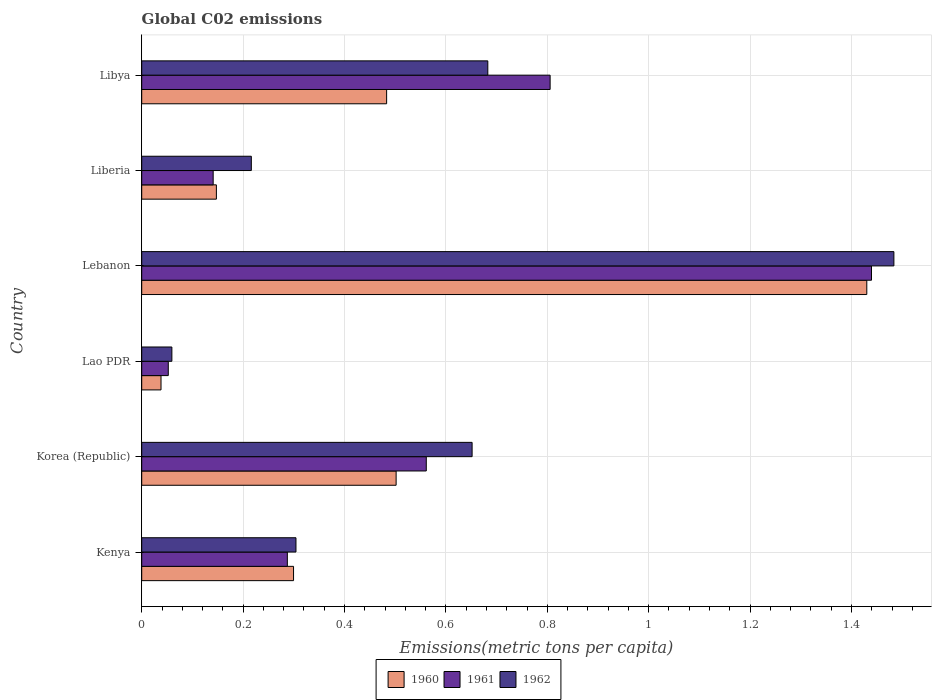How many groups of bars are there?
Your response must be concise. 6. Are the number of bars per tick equal to the number of legend labels?
Offer a very short reply. Yes. Are the number of bars on each tick of the Y-axis equal?
Ensure brevity in your answer.  Yes. What is the label of the 2nd group of bars from the top?
Your answer should be very brief. Liberia. In how many cases, is the number of bars for a given country not equal to the number of legend labels?
Make the answer very short. 0. What is the amount of CO2 emitted in in 1960 in Lao PDR?
Provide a succinct answer. 0.04. Across all countries, what is the maximum amount of CO2 emitted in in 1960?
Provide a succinct answer. 1.43. Across all countries, what is the minimum amount of CO2 emitted in in 1962?
Your answer should be compact. 0.06. In which country was the amount of CO2 emitted in in 1960 maximum?
Offer a terse response. Lebanon. In which country was the amount of CO2 emitted in in 1960 minimum?
Give a very brief answer. Lao PDR. What is the total amount of CO2 emitted in in 1960 in the graph?
Give a very brief answer. 2.9. What is the difference between the amount of CO2 emitted in in 1960 in Lao PDR and that in Liberia?
Give a very brief answer. -0.11. What is the difference between the amount of CO2 emitted in in 1961 in Liberia and the amount of CO2 emitted in in 1962 in Lebanon?
Provide a short and direct response. -1.34. What is the average amount of CO2 emitted in in 1962 per country?
Ensure brevity in your answer.  0.57. What is the difference between the amount of CO2 emitted in in 1962 and amount of CO2 emitted in in 1961 in Lebanon?
Offer a terse response. 0.04. In how many countries, is the amount of CO2 emitted in in 1961 greater than 0.24000000000000002 metric tons per capita?
Offer a very short reply. 4. What is the ratio of the amount of CO2 emitted in in 1961 in Kenya to that in Korea (Republic)?
Make the answer very short. 0.51. Is the amount of CO2 emitted in in 1962 in Lebanon less than that in Libya?
Your response must be concise. No. Is the difference between the amount of CO2 emitted in in 1962 in Kenya and Korea (Republic) greater than the difference between the amount of CO2 emitted in in 1961 in Kenya and Korea (Republic)?
Ensure brevity in your answer.  No. What is the difference between the highest and the second highest amount of CO2 emitted in in 1961?
Your answer should be very brief. 0.63. What is the difference between the highest and the lowest amount of CO2 emitted in in 1962?
Provide a short and direct response. 1.42. Is the sum of the amount of CO2 emitted in in 1962 in Kenya and Libya greater than the maximum amount of CO2 emitted in in 1960 across all countries?
Your answer should be very brief. No. How many bars are there?
Your response must be concise. 18. Are all the bars in the graph horizontal?
Provide a short and direct response. Yes. How many countries are there in the graph?
Your answer should be compact. 6. Does the graph contain grids?
Provide a succinct answer. Yes. Where does the legend appear in the graph?
Keep it short and to the point. Bottom center. How many legend labels are there?
Make the answer very short. 3. How are the legend labels stacked?
Make the answer very short. Horizontal. What is the title of the graph?
Make the answer very short. Global C02 emissions. Does "1995" appear as one of the legend labels in the graph?
Provide a short and direct response. No. What is the label or title of the X-axis?
Offer a very short reply. Emissions(metric tons per capita). What is the label or title of the Y-axis?
Offer a very short reply. Country. What is the Emissions(metric tons per capita) of 1960 in Kenya?
Your answer should be compact. 0.3. What is the Emissions(metric tons per capita) in 1961 in Kenya?
Your answer should be very brief. 0.29. What is the Emissions(metric tons per capita) in 1962 in Kenya?
Your answer should be very brief. 0.3. What is the Emissions(metric tons per capita) in 1960 in Korea (Republic)?
Offer a very short reply. 0.5. What is the Emissions(metric tons per capita) in 1961 in Korea (Republic)?
Offer a very short reply. 0.56. What is the Emissions(metric tons per capita) of 1962 in Korea (Republic)?
Your answer should be very brief. 0.65. What is the Emissions(metric tons per capita) of 1960 in Lao PDR?
Your answer should be very brief. 0.04. What is the Emissions(metric tons per capita) in 1961 in Lao PDR?
Your answer should be very brief. 0.05. What is the Emissions(metric tons per capita) in 1962 in Lao PDR?
Provide a succinct answer. 0.06. What is the Emissions(metric tons per capita) of 1960 in Lebanon?
Provide a succinct answer. 1.43. What is the Emissions(metric tons per capita) in 1961 in Lebanon?
Keep it short and to the point. 1.44. What is the Emissions(metric tons per capita) of 1962 in Lebanon?
Your answer should be very brief. 1.48. What is the Emissions(metric tons per capita) of 1960 in Liberia?
Give a very brief answer. 0.15. What is the Emissions(metric tons per capita) of 1961 in Liberia?
Provide a succinct answer. 0.14. What is the Emissions(metric tons per capita) in 1962 in Liberia?
Provide a short and direct response. 0.22. What is the Emissions(metric tons per capita) in 1960 in Libya?
Your answer should be compact. 0.48. What is the Emissions(metric tons per capita) in 1961 in Libya?
Keep it short and to the point. 0.81. What is the Emissions(metric tons per capita) of 1962 in Libya?
Give a very brief answer. 0.68. Across all countries, what is the maximum Emissions(metric tons per capita) of 1960?
Provide a succinct answer. 1.43. Across all countries, what is the maximum Emissions(metric tons per capita) of 1961?
Your response must be concise. 1.44. Across all countries, what is the maximum Emissions(metric tons per capita) in 1962?
Provide a succinct answer. 1.48. Across all countries, what is the minimum Emissions(metric tons per capita) in 1960?
Offer a very short reply. 0.04. Across all countries, what is the minimum Emissions(metric tons per capita) of 1961?
Give a very brief answer. 0.05. Across all countries, what is the minimum Emissions(metric tons per capita) of 1962?
Your response must be concise. 0.06. What is the total Emissions(metric tons per capita) of 1960 in the graph?
Offer a very short reply. 2.9. What is the total Emissions(metric tons per capita) of 1961 in the graph?
Provide a short and direct response. 3.29. What is the total Emissions(metric tons per capita) in 1962 in the graph?
Your answer should be compact. 3.4. What is the difference between the Emissions(metric tons per capita) in 1960 in Kenya and that in Korea (Republic)?
Your answer should be very brief. -0.2. What is the difference between the Emissions(metric tons per capita) in 1961 in Kenya and that in Korea (Republic)?
Your response must be concise. -0.27. What is the difference between the Emissions(metric tons per capita) in 1962 in Kenya and that in Korea (Republic)?
Your response must be concise. -0.35. What is the difference between the Emissions(metric tons per capita) of 1960 in Kenya and that in Lao PDR?
Give a very brief answer. 0.26. What is the difference between the Emissions(metric tons per capita) of 1961 in Kenya and that in Lao PDR?
Give a very brief answer. 0.23. What is the difference between the Emissions(metric tons per capita) of 1962 in Kenya and that in Lao PDR?
Your answer should be compact. 0.24. What is the difference between the Emissions(metric tons per capita) of 1960 in Kenya and that in Lebanon?
Offer a very short reply. -1.13. What is the difference between the Emissions(metric tons per capita) of 1961 in Kenya and that in Lebanon?
Keep it short and to the point. -1.15. What is the difference between the Emissions(metric tons per capita) of 1962 in Kenya and that in Lebanon?
Keep it short and to the point. -1.18. What is the difference between the Emissions(metric tons per capita) of 1960 in Kenya and that in Liberia?
Ensure brevity in your answer.  0.15. What is the difference between the Emissions(metric tons per capita) in 1961 in Kenya and that in Liberia?
Provide a succinct answer. 0.15. What is the difference between the Emissions(metric tons per capita) in 1962 in Kenya and that in Liberia?
Your answer should be very brief. 0.09. What is the difference between the Emissions(metric tons per capita) of 1960 in Kenya and that in Libya?
Give a very brief answer. -0.18. What is the difference between the Emissions(metric tons per capita) in 1961 in Kenya and that in Libya?
Your answer should be very brief. -0.52. What is the difference between the Emissions(metric tons per capita) of 1962 in Kenya and that in Libya?
Your answer should be compact. -0.38. What is the difference between the Emissions(metric tons per capita) in 1960 in Korea (Republic) and that in Lao PDR?
Your answer should be very brief. 0.46. What is the difference between the Emissions(metric tons per capita) of 1961 in Korea (Republic) and that in Lao PDR?
Provide a succinct answer. 0.51. What is the difference between the Emissions(metric tons per capita) of 1962 in Korea (Republic) and that in Lao PDR?
Make the answer very short. 0.59. What is the difference between the Emissions(metric tons per capita) in 1960 in Korea (Republic) and that in Lebanon?
Your response must be concise. -0.93. What is the difference between the Emissions(metric tons per capita) of 1961 in Korea (Republic) and that in Lebanon?
Provide a succinct answer. -0.88. What is the difference between the Emissions(metric tons per capita) in 1962 in Korea (Republic) and that in Lebanon?
Provide a short and direct response. -0.83. What is the difference between the Emissions(metric tons per capita) in 1960 in Korea (Republic) and that in Liberia?
Offer a terse response. 0.35. What is the difference between the Emissions(metric tons per capita) in 1961 in Korea (Republic) and that in Liberia?
Offer a very short reply. 0.42. What is the difference between the Emissions(metric tons per capita) of 1962 in Korea (Republic) and that in Liberia?
Your response must be concise. 0.44. What is the difference between the Emissions(metric tons per capita) of 1960 in Korea (Republic) and that in Libya?
Offer a terse response. 0.02. What is the difference between the Emissions(metric tons per capita) in 1961 in Korea (Republic) and that in Libya?
Keep it short and to the point. -0.24. What is the difference between the Emissions(metric tons per capita) of 1962 in Korea (Republic) and that in Libya?
Your answer should be compact. -0.03. What is the difference between the Emissions(metric tons per capita) of 1960 in Lao PDR and that in Lebanon?
Make the answer very short. -1.39. What is the difference between the Emissions(metric tons per capita) of 1961 in Lao PDR and that in Lebanon?
Offer a very short reply. -1.39. What is the difference between the Emissions(metric tons per capita) in 1962 in Lao PDR and that in Lebanon?
Keep it short and to the point. -1.42. What is the difference between the Emissions(metric tons per capita) of 1960 in Lao PDR and that in Liberia?
Keep it short and to the point. -0.11. What is the difference between the Emissions(metric tons per capita) of 1961 in Lao PDR and that in Liberia?
Offer a terse response. -0.09. What is the difference between the Emissions(metric tons per capita) in 1962 in Lao PDR and that in Liberia?
Your answer should be compact. -0.16. What is the difference between the Emissions(metric tons per capita) in 1960 in Lao PDR and that in Libya?
Offer a terse response. -0.45. What is the difference between the Emissions(metric tons per capita) of 1961 in Lao PDR and that in Libya?
Keep it short and to the point. -0.75. What is the difference between the Emissions(metric tons per capita) of 1962 in Lao PDR and that in Libya?
Offer a terse response. -0.62. What is the difference between the Emissions(metric tons per capita) of 1960 in Lebanon and that in Liberia?
Offer a terse response. 1.28. What is the difference between the Emissions(metric tons per capita) in 1961 in Lebanon and that in Liberia?
Provide a short and direct response. 1.3. What is the difference between the Emissions(metric tons per capita) of 1962 in Lebanon and that in Liberia?
Provide a succinct answer. 1.27. What is the difference between the Emissions(metric tons per capita) of 1960 in Lebanon and that in Libya?
Your answer should be compact. 0.95. What is the difference between the Emissions(metric tons per capita) of 1961 in Lebanon and that in Libya?
Give a very brief answer. 0.63. What is the difference between the Emissions(metric tons per capita) in 1962 in Lebanon and that in Libya?
Keep it short and to the point. 0.8. What is the difference between the Emissions(metric tons per capita) of 1960 in Liberia and that in Libya?
Provide a short and direct response. -0.34. What is the difference between the Emissions(metric tons per capita) of 1961 in Liberia and that in Libya?
Your answer should be very brief. -0.66. What is the difference between the Emissions(metric tons per capita) in 1962 in Liberia and that in Libya?
Your answer should be very brief. -0.47. What is the difference between the Emissions(metric tons per capita) in 1960 in Kenya and the Emissions(metric tons per capita) in 1961 in Korea (Republic)?
Make the answer very short. -0.26. What is the difference between the Emissions(metric tons per capita) in 1960 in Kenya and the Emissions(metric tons per capita) in 1962 in Korea (Republic)?
Your response must be concise. -0.35. What is the difference between the Emissions(metric tons per capita) of 1961 in Kenya and the Emissions(metric tons per capita) of 1962 in Korea (Republic)?
Make the answer very short. -0.36. What is the difference between the Emissions(metric tons per capita) of 1960 in Kenya and the Emissions(metric tons per capita) of 1961 in Lao PDR?
Provide a succinct answer. 0.25. What is the difference between the Emissions(metric tons per capita) in 1960 in Kenya and the Emissions(metric tons per capita) in 1962 in Lao PDR?
Give a very brief answer. 0.24. What is the difference between the Emissions(metric tons per capita) of 1961 in Kenya and the Emissions(metric tons per capita) of 1962 in Lao PDR?
Keep it short and to the point. 0.23. What is the difference between the Emissions(metric tons per capita) in 1960 in Kenya and the Emissions(metric tons per capita) in 1961 in Lebanon?
Your answer should be compact. -1.14. What is the difference between the Emissions(metric tons per capita) in 1960 in Kenya and the Emissions(metric tons per capita) in 1962 in Lebanon?
Make the answer very short. -1.18. What is the difference between the Emissions(metric tons per capita) in 1961 in Kenya and the Emissions(metric tons per capita) in 1962 in Lebanon?
Give a very brief answer. -1.2. What is the difference between the Emissions(metric tons per capita) in 1960 in Kenya and the Emissions(metric tons per capita) in 1961 in Liberia?
Your response must be concise. 0.16. What is the difference between the Emissions(metric tons per capita) in 1960 in Kenya and the Emissions(metric tons per capita) in 1962 in Liberia?
Offer a terse response. 0.08. What is the difference between the Emissions(metric tons per capita) in 1961 in Kenya and the Emissions(metric tons per capita) in 1962 in Liberia?
Give a very brief answer. 0.07. What is the difference between the Emissions(metric tons per capita) in 1960 in Kenya and the Emissions(metric tons per capita) in 1961 in Libya?
Your answer should be very brief. -0.51. What is the difference between the Emissions(metric tons per capita) in 1960 in Kenya and the Emissions(metric tons per capita) in 1962 in Libya?
Provide a succinct answer. -0.38. What is the difference between the Emissions(metric tons per capita) in 1961 in Kenya and the Emissions(metric tons per capita) in 1962 in Libya?
Make the answer very short. -0.4. What is the difference between the Emissions(metric tons per capita) in 1960 in Korea (Republic) and the Emissions(metric tons per capita) in 1961 in Lao PDR?
Provide a succinct answer. 0.45. What is the difference between the Emissions(metric tons per capita) in 1960 in Korea (Republic) and the Emissions(metric tons per capita) in 1962 in Lao PDR?
Provide a succinct answer. 0.44. What is the difference between the Emissions(metric tons per capita) of 1961 in Korea (Republic) and the Emissions(metric tons per capita) of 1962 in Lao PDR?
Provide a short and direct response. 0.5. What is the difference between the Emissions(metric tons per capita) of 1960 in Korea (Republic) and the Emissions(metric tons per capita) of 1961 in Lebanon?
Give a very brief answer. -0.94. What is the difference between the Emissions(metric tons per capita) in 1960 in Korea (Republic) and the Emissions(metric tons per capita) in 1962 in Lebanon?
Ensure brevity in your answer.  -0.98. What is the difference between the Emissions(metric tons per capita) in 1961 in Korea (Republic) and the Emissions(metric tons per capita) in 1962 in Lebanon?
Your response must be concise. -0.92. What is the difference between the Emissions(metric tons per capita) in 1960 in Korea (Republic) and the Emissions(metric tons per capita) in 1961 in Liberia?
Give a very brief answer. 0.36. What is the difference between the Emissions(metric tons per capita) in 1960 in Korea (Republic) and the Emissions(metric tons per capita) in 1962 in Liberia?
Keep it short and to the point. 0.29. What is the difference between the Emissions(metric tons per capita) of 1961 in Korea (Republic) and the Emissions(metric tons per capita) of 1962 in Liberia?
Your answer should be very brief. 0.35. What is the difference between the Emissions(metric tons per capita) of 1960 in Korea (Republic) and the Emissions(metric tons per capita) of 1961 in Libya?
Provide a short and direct response. -0.3. What is the difference between the Emissions(metric tons per capita) of 1960 in Korea (Republic) and the Emissions(metric tons per capita) of 1962 in Libya?
Make the answer very short. -0.18. What is the difference between the Emissions(metric tons per capita) in 1961 in Korea (Republic) and the Emissions(metric tons per capita) in 1962 in Libya?
Your response must be concise. -0.12. What is the difference between the Emissions(metric tons per capita) of 1960 in Lao PDR and the Emissions(metric tons per capita) of 1961 in Lebanon?
Your response must be concise. -1.4. What is the difference between the Emissions(metric tons per capita) of 1960 in Lao PDR and the Emissions(metric tons per capita) of 1962 in Lebanon?
Provide a short and direct response. -1.45. What is the difference between the Emissions(metric tons per capita) in 1961 in Lao PDR and the Emissions(metric tons per capita) in 1962 in Lebanon?
Ensure brevity in your answer.  -1.43. What is the difference between the Emissions(metric tons per capita) of 1960 in Lao PDR and the Emissions(metric tons per capita) of 1961 in Liberia?
Provide a succinct answer. -0.1. What is the difference between the Emissions(metric tons per capita) in 1960 in Lao PDR and the Emissions(metric tons per capita) in 1962 in Liberia?
Provide a short and direct response. -0.18. What is the difference between the Emissions(metric tons per capita) of 1961 in Lao PDR and the Emissions(metric tons per capita) of 1962 in Liberia?
Give a very brief answer. -0.16. What is the difference between the Emissions(metric tons per capita) of 1960 in Lao PDR and the Emissions(metric tons per capita) of 1961 in Libya?
Provide a succinct answer. -0.77. What is the difference between the Emissions(metric tons per capita) of 1960 in Lao PDR and the Emissions(metric tons per capita) of 1962 in Libya?
Ensure brevity in your answer.  -0.64. What is the difference between the Emissions(metric tons per capita) of 1961 in Lao PDR and the Emissions(metric tons per capita) of 1962 in Libya?
Ensure brevity in your answer.  -0.63. What is the difference between the Emissions(metric tons per capita) of 1960 in Lebanon and the Emissions(metric tons per capita) of 1961 in Liberia?
Ensure brevity in your answer.  1.29. What is the difference between the Emissions(metric tons per capita) in 1960 in Lebanon and the Emissions(metric tons per capita) in 1962 in Liberia?
Provide a succinct answer. 1.21. What is the difference between the Emissions(metric tons per capita) in 1961 in Lebanon and the Emissions(metric tons per capita) in 1962 in Liberia?
Provide a short and direct response. 1.22. What is the difference between the Emissions(metric tons per capita) in 1960 in Lebanon and the Emissions(metric tons per capita) in 1961 in Libya?
Provide a short and direct response. 0.62. What is the difference between the Emissions(metric tons per capita) in 1960 in Lebanon and the Emissions(metric tons per capita) in 1962 in Libya?
Provide a short and direct response. 0.75. What is the difference between the Emissions(metric tons per capita) of 1961 in Lebanon and the Emissions(metric tons per capita) of 1962 in Libya?
Provide a short and direct response. 0.76. What is the difference between the Emissions(metric tons per capita) in 1960 in Liberia and the Emissions(metric tons per capita) in 1961 in Libya?
Give a very brief answer. -0.66. What is the difference between the Emissions(metric tons per capita) of 1960 in Liberia and the Emissions(metric tons per capita) of 1962 in Libya?
Make the answer very short. -0.54. What is the difference between the Emissions(metric tons per capita) of 1961 in Liberia and the Emissions(metric tons per capita) of 1962 in Libya?
Provide a short and direct response. -0.54. What is the average Emissions(metric tons per capita) in 1960 per country?
Your answer should be very brief. 0.48. What is the average Emissions(metric tons per capita) in 1961 per country?
Ensure brevity in your answer.  0.55. What is the average Emissions(metric tons per capita) of 1962 per country?
Make the answer very short. 0.57. What is the difference between the Emissions(metric tons per capita) of 1960 and Emissions(metric tons per capita) of 1961 in Kenya?
Keep it short and to the point. 0.01. What is the difference between the Emissions(metric tons per capita) in 1960 and Emissions(metric tons per capita) in 1962 in Kenya?
Keep it short and to the point. -0. What is the difference between the Emissions(metric tons per capita) in 1961 and Emissions(metric tons per capita) in 1962 in Kenya?
Your answer should be compact. -0.02. What is the difference between the Emissions(metric tons per capita) of 1960 and Emissions(metric tons per capita) of 1961 in Korea (Republic)?
Provide a short and direct response. -0.06. What is the difference between the Emissions(metric tons per capita) in 1960 and Emissions(metric tons per capita) in 1962 in Korea (Republic)?
Your answer should be compact. -0.15. What is the difference between the Emissions(metric tons per capita) in 1961 and Emissions(metric tons per capita) in 1962 in Korea (Republic)?
Your response must be concise. -0.09. What is the difference between the Emissions(metric tons per capita) of 1960 and Emissions(metric tons per capita) of 1961 in Lao PDR?
Offer a terse response. -0.01. What is the difference between the Emissions(metric tons per capita) of 1960 and Emissions(metric tons per capita) of 1962 in Lao PDR?
Your answer should be very brief. -0.02. What is the difference between the Emissions(metric tons per capita) in 1961 and Emissions(metric tons per capita) in 1962 in Lao PDR?
Ensure brevity in your answer.  -0.01. What is the difference between the Emissions(metric tons per capita) of 1960 and Emissions(metric tons per capita) of 1961 in Lebanon?
Make the answer very short. -0.01. What is the difference between the Emissions(metric tons per capita) of 1960 and Emissions(metric tons per capita) of 1962 in Lebanon?
Keep it short and to the point. -0.05. What is the difference between the Emissions(metric tons per capita) of 1961 and Emissions(metric tons per capita) of 1962 in Lebanon?
Keep it short and to the point. -0.04. What is the difference between the Emissions(metric tons per capita) in 1960 and Emissions(metric tons per capita) in 1961 in Liberia?
Give a very brief answer. 0.01. What is the difference between the Emissions(metric tons per capita) of 1960 and Emissions(metric tons per capita) of 1962 in Liberia?
Offer a terse response. -0.07. What is the difference between the Emissions(metric tons per capita) of 1961 and Emissions(metric tons per capita) of 1962 in Liberia?
Your answer should be very brief. -0.08. What is the difference between the Emissions(metric tons per capita) in 1960 and Emissions(metric tons per capita) in 1961 in Libya?
Make the answer very short. -0.32. What is the difference between the Emissions(metric tons per capita) of 1960 and Emissions(metric tons per capita) of 1962 in Libya?
Offer a very short reply. -0.2. What is the difference between the Emissions(metric tons per capita) in 1961 and Emissions(metric tons per capita) in 1962 in Libya?
Make the answer very short. 0.12. What is the ratio of the Emissions(metric tons per capita) of 1960 in Kenya to that in Korea (Republic)?
Make the answer very short. 0.6. What is the ratio of the Emissions(metric tons per capita) of 1961 in Kenya to that in Korea (Republic)?
Ensure brevity in your answer.  0.51. What is the ratio of the Emissions(metric tons per capita) of 1962 in Kenya to that in Korea (Republic)?
Offer a terse response. 0.47. What is the ratio of the Emissions(metric tons per capita) of 1960 in Kenya to that in Lao PDR?
Your response must be concise. 7.87. What is the ratio of the Emissions(metric tons per capita) of 1961 in Kenya to that in Lao PDR?
Provide a succinct answer. 5.48. What is the ratio of the Emissions(metric tons per capita) in 1962 in Kenya to that in Lao PDR?
Provide a succinct answer. 5.12. What is the ratio of the Emissions(metric tons per capita) in 1960 in Kenya to that in Lebanon?
Your answer should be compact. 0.21. What is the ratio of the Emissions(metric tons per capita) in 1961 in Kenya to that in Lebanon?
Provide a short and direct response. 0.2. What is the ratio of the Emissions(metric tons per capita) in 1962 in Kenya to that in Lebanon?
Provide a short and direct response. 0.21. What is the ratio of the Emissions(metric tons per capita) in 1960 in Kenya to that in Liberia?
Your answer should be very brief. 2.03. What is the ratio of the Emissions(metric tons per capita) of 1961 in Kenya to that in Liberia?
Give a very brief answer. 2.04. What is the ratio of the Emissions(metric tons per capita) in 1962 in Kenya to that in Liberia?
Your response must be concise. 1.41. What is the ratio of the Emissions(metric tons per capita) in 1960 in Kenya to that in Libya?
Make the answer very short. 0.62. What is the ratio of the Emissions(metric tons per capita) in 1961 in Kenya to that in Libya?
Offer a very short reply. 0.36. What is the ratio of the Emissions(metric tons per capita) of 1962 in Kenya to that in Libya?
Your answer should be very brief. 0.45. What is the ratio of the Emissions(metric tons per capita) of 1960 in Korea (Republic) to that in Lao PDR?
Your answer should be very brief. 13.19. What is the ratio of the Emissions(metric tons per capita) of 1961 in Korea (Republic) to that in Lao PDR?
Keep it short and to the point. 10.71. What is the ratio of the Emissions(metric tons per capita) of 1962 in Korea (Republic) to that in Lao PDR?
Give a very brief answer. 10.96. What is the ratio of the Emissions(metric tons per capita) in 1960 in Korea (Republic) to that in Lebanon?
Provide a succinct answer. 0.35. What is the ratio of the Emissions(metric tons per capita) in 1961 in Korea (Republic) to that in Lebanon?
Offer a terse response. 0.39. What is the ratio of the Emissions(metric tons per capita) of 1962 in Korea (Republic) to that in Lebanon?
Your answer should be compact. 0.44. What is the ratio of the Emissions(metric tons per capita) in 1960 in Korea (Republic) to that in Liberia?
Offer a terse response. 3.41. What is the ratio of the Emissions(metric tons per capita) in 1961 in Korea (Republic) to that in Liberia?
Your answer should be very brief. 3.98. What is the ratio of the Emissions(metric tons per capita) in 1962 in Korea (Republic) to that in Liberia?
Make the answer very short. 3.01. What is the ratio of the Emissions(metric tons per capita) of 1960 in Korea (Republic) to that in Libya?
Provide a short and direct response. 1.04. What is the ratio of the Emissions(metric tons per capita) of 1961 in Korea (Republic) to that in Libya?
Give a very brief answer. 0.7. What is the ratio of the Emissions(metric tons per capita) of 1962 in Korea (Republic) to that in Libya?
Provide a short and direct response. 0.95. What is the ratio of the Emissions(metric tons per capita) in 1960 in Lao PDR to that in Lebanon?
Your answer should be compact. 0.03. What is the ratio of the Emissions(metric tons per capita) of 1961 in Lao PDR to that in Lebanon?
Provide a succinct answer. 0.04. What is the ratio of the Emissions(metric tons per capita) in 1962 in Lao PDR to that in Lebanon?
Offer a very short reply. 0.04. What is the ratio of the Emissions(metric tons per capita) in 1960 in Lao PDR to that in Liberia?
Your answer should be compact. 0.26. What is the ratio of the Emissions(metric tons per capita) of 1961 in Lao PDR to that in Liberia?
Offer a very short reply. 0.37. What is the ratio of the Emissions(metric tons per capita) of 1962 in Lao PDR to that in Liberia?
Provide a short and direct response. 0.28. What is the ratio of the Emissions(metric tons per capita) in 1960 in Lao PDR to that in Libya?
Provide a short and direct response. 0.08. What is the ratio of the Emissions(metric tons per capita) in 1961 in Lao PDR to that in Libya?
Give a very brief answer. 0.07. What is the ratio of the Emissions(metric tons per capita) in 1962 in Lao PDR to that in Libya?
Your response must be concise. 0.09. What is the ratio of the Emissions(metric tons per capita) of 1960 in Lebanon to that in Liberia?
Ensure brevity in your answer.  9.71. What is the ratio of the Emissions(metric tons per capita) in 1961 in Lebanon to that in Liberia?
Ensure brevity in your answer.  10.21. What is the ratio of the Emissions(metric tons per capita) of 1962 in Lebanon to that in Liberia?
Ensure brevity in your answer.  6.86. What is the ratio of the Emissions(metric tons per capita) in 1960 in Lebanon to that in Libya?
Make the answer very short. 2.96. What is the ratio of the Emissions(metric tons per capita) in 1961 in Lebanon to that in Libya?
Give a very brief answer. 1.79. What is the ratio of the Emissions(metric tons per capita) in 1962 in Lebanon to that in Libya?
Your response must be concise. 2.17. What is the ratio of the Emissions(metric tons per capita) of 1960 in Liberia to that in Libya?
Provide a short and direct response. 0.3. What is the ratio of the Emissions(metric tons per capita) of 1961 in Liberia to that in Libya?
Provide a short and direct response. 0.17. What is the ratio of the Emissions(metric tons per capita) of 1962 in Liberia to that in Libya?
Ensure brevity in your answer.  0.32. What is the difference between the highest and the second highest Emissions(metric tons per capita) in 1960?
Make the answer very short. 0.93. What is the difference between the highest and the second highest Emissions(metric tons per capita) of 1961?
Provide a succinct answer. 0.63. What is the difference between the highest and the second highest Emissions(metric tons per capita) of 1962?
Offer a terse response. 0.8. What is the difference between the highest and the lowest Emissions(metric tons per capita) in 1960?
Offer a very short reply. 1.39. What is the difference between the highest and the lowest Emissions(metric tons per capita) in 1961?
Offer a terse response. 1.39. What is the difference between the highest and the lowest Emissions(metric tons per capita) in 1962?
Give a very brief answer. 1.42. 